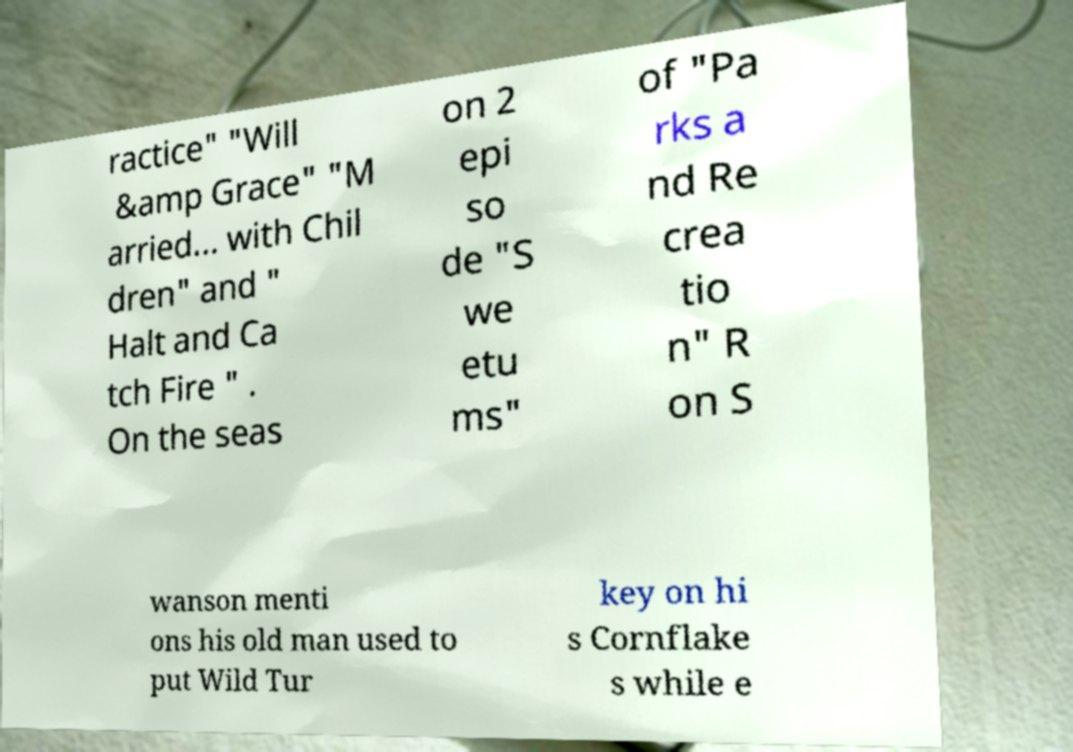Please identify and transcribe the text found in this image. ractice" "Will &amp Grace" "M arried... with Chil dren" and " Halt and Ca tch Fire " . On the seas on 2 epi so de "S we etu ms" of "Pa rks a nd Re crea tio n" R on S wanson menti ons his old man used to put Wild Tur key on hi s Cornflake s while e 